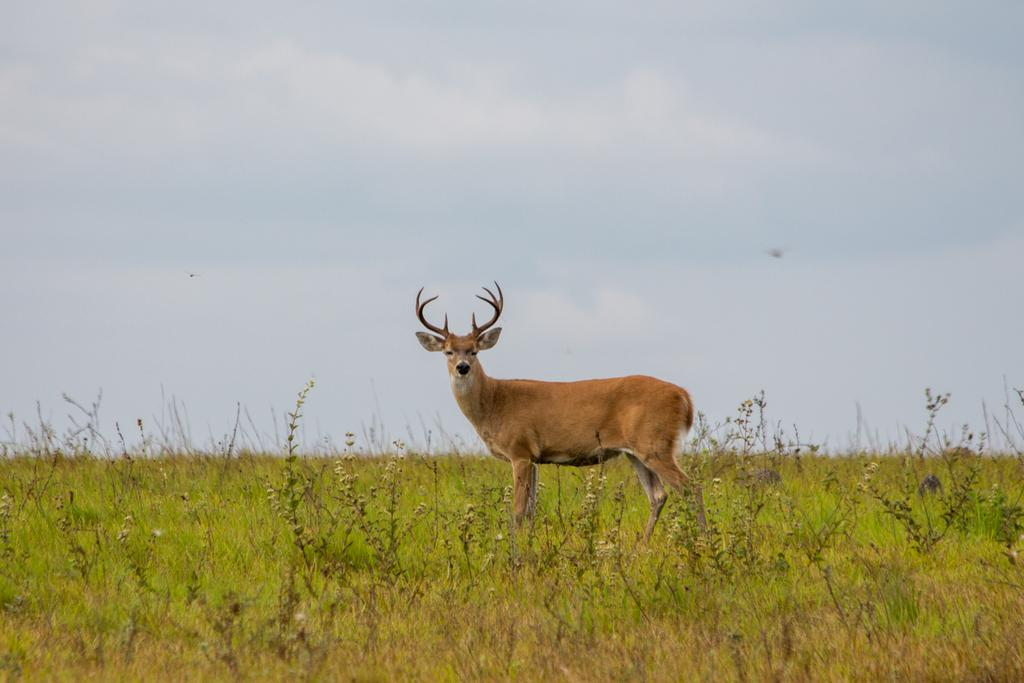What animal is present in the image? There is a deer in the image. Where is the deer located? The deer is on the grass. What can be seen in the background of the image? The sky is visible in the background of the image. What type of zephyr is blowing through the image? There is no mention of a zephyr in the image, so it cannot be determined if one is present or what type it might be. 